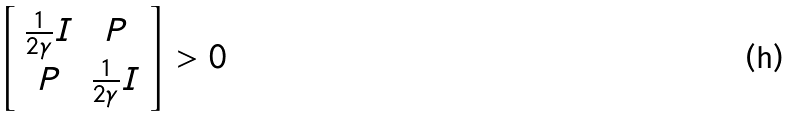Convert formula to latex. <formula><loc_0><loc_0><loc_500><loc_500>\left [ \begin{array} { c c } \frac { 1 } { 2 \gamma } I & P \\ P & \frac { 1 } { 2 \gamma } I \\ \end{array} \right ] > 0</formula> 